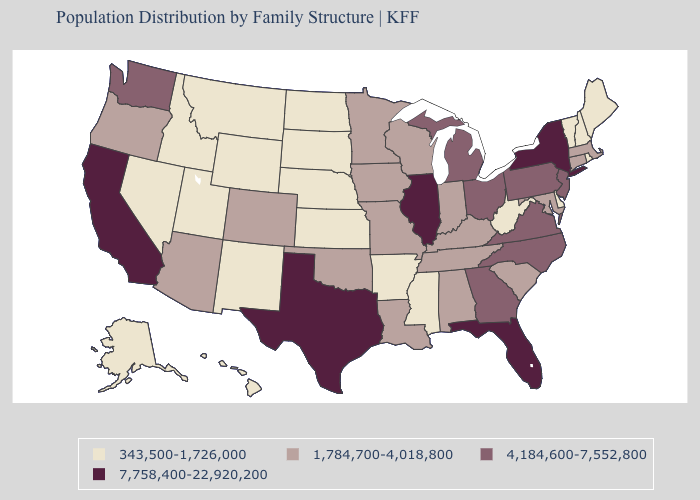What is the value of Nebraska?
Quick response, please. 343,500-1,726,000. What is the highest value in states that border Arizona?
Concise answer only. 7,758,400-22,920,200. Among the states that border South Dakota , which have the highest value?
Answer briefly. Iowa, Minnesota. What is the value of Michigan?
Write a very short answer. 4,184,600-7,552,800. Name the states that have a value in the range 4,184,600-7,552,800?
Short answer required. Georgia, Michigan, New Jersey, North Carolina, Ohio, Pennsylvania, Virginia, Washington. What is the lowest value in the USA?
Give a very brief answer. 343,500-1,726,000. Is the legend a continuous bar?
Answer briefly. No. What is the value of Colorado?
Give a very brief answer. 1,784,700-4,018,800. What is the lowest value in the West?
Answer briefly. 343,500-1,726,000. Does New Hampshire have a lower value than Mississippi?
Short answer required. No. Name the states that have a value in the range 343,500-1,726,000?
Concise answer only. Alaska, Arkansas, Delaware, Hawaii, Idaho, Kansas, Maine, Mississippi, Montana, Nebraska, Nevada, New Hampshire, New Mexico, North Dakota, Rhode Island, South Dakota, Utah, Vermont, West Virginia, Wyoming. Does Wyoming have the lowest value in the USA?
Quick response, please. Yes. What is the lowest value in the USA?
Write a very short answer. 343,500-1,726,000. Among the states that border North Dakota , does Minnesota have the lowest value?
Concise answer only. No. What is the highest value in the USA?
Write a very short answer. 7,758,400-22,920,200. 